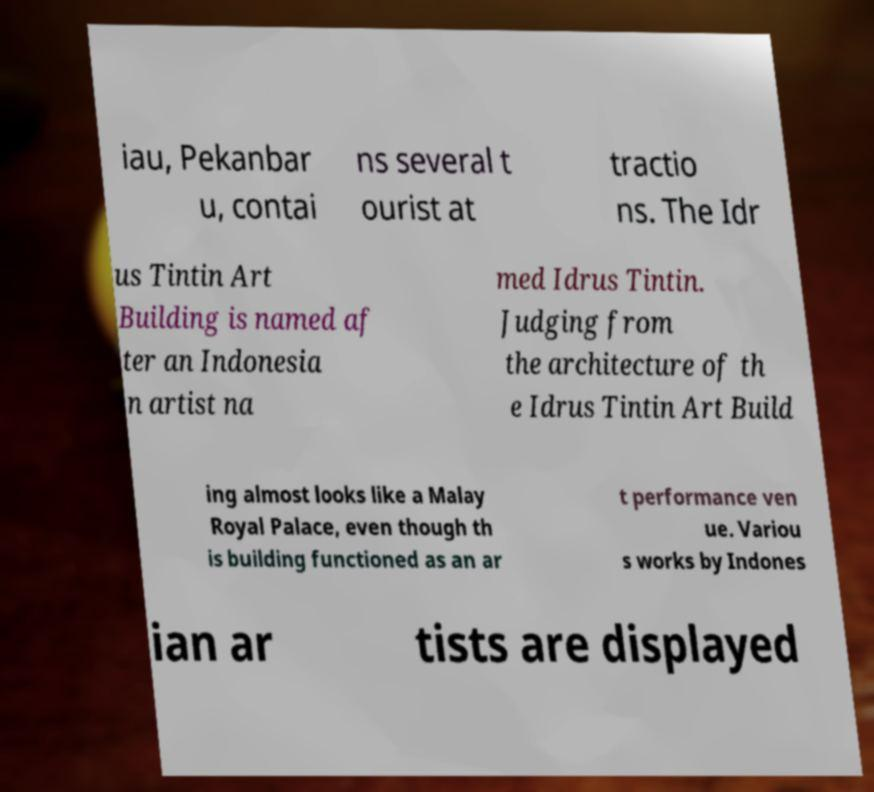There's text embedded in this image that I need extracted. Can you transcribe it verbatim? iau, Pekanbar u, contai ns several t ourist at tractio ns. The Idr us Tintin Art Building is named af ter an Indonesia n artist na med Idrus Tintin. Judging from the architecture of th e Idrus Tintin Art Build ing almost looks like a Malay Royal Palace, even though th is building functioned as an ar t performance ven ue. Variou s works by Indones ian ar tists are displayed 